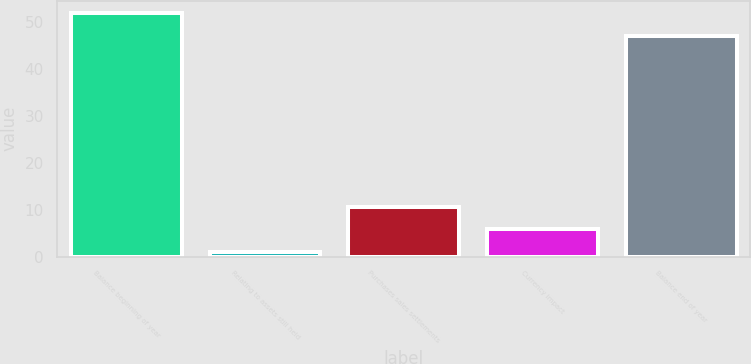Convert chart to OTSL. <chart><loc_0><loc_0><loc_500><loc_500><bar_chart><fcel>Balance beginning of year<fcel>Relating to assets still held<fcel>Purchases sales settlements<fcel>Currency impact<fcel>Balance end of year<nl><fcel>51.8<fcel>1<fcel>10.6<fcel>5.8<fcel>47<nl></chart> 